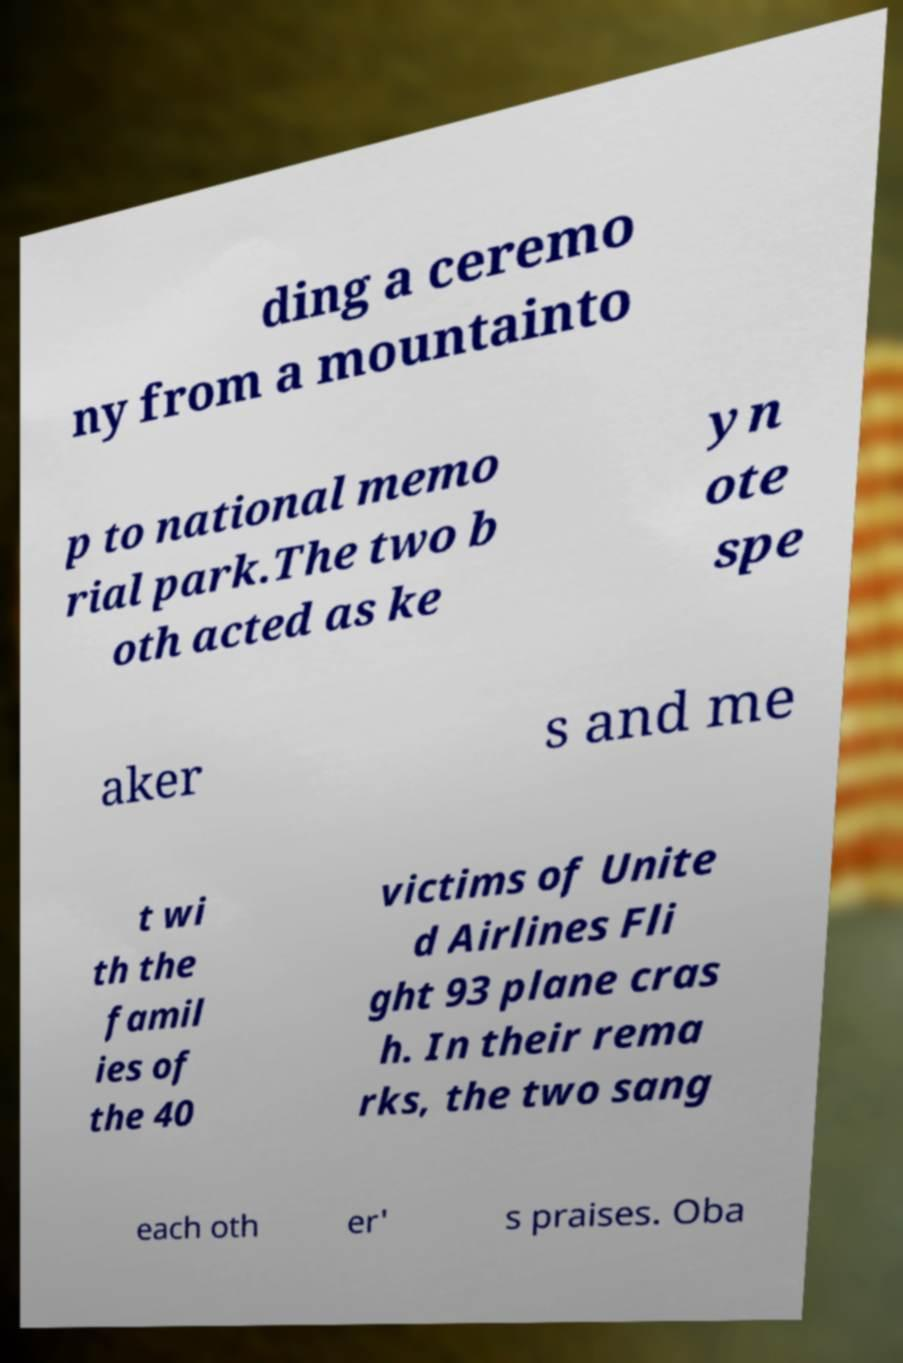Can you read and provide the text displayed in the image?This photo seems to have some interesting text. Can you extract and type it out for me? ding a ceremo ny from a mountainto p to national memo rial park.The two b oth acted as ke yn ote spe aker s and me t wi th the famil ies of the 40 victims of Unite d Airlines Fli ght 93 plane cras h. In their rema rks, the two sang each oth er' s praises. Oba 